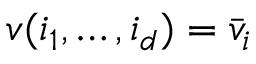<formula> <loc_0><loc_0><loc_500><loc_500>v ( i _ { 1 } , \dots , i _ { d } ) = \bar { v } _ { i }</formula> 